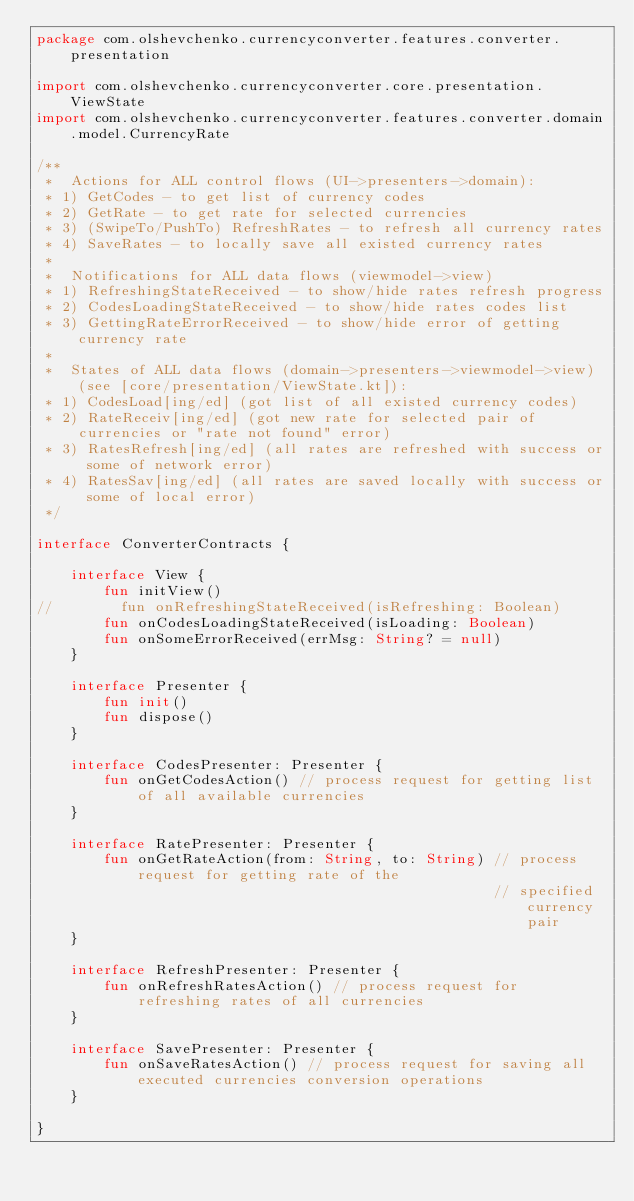<code> <loc_0><loc_0><loc_500><loc_500><_Kotlin_>package com.olshevchenko.currencyconverter.features.converter.presentation

import com.olshevchenko.currencyconverter.core.presentation.ViewState
import com.olshevchenko.currencyconverter.features.converter.domain.model.CurrencyRate

/**
 *  Actions for ALL control flows (UI->presenters->domain):
 * 1) GetCodes - to get list of currency codes
 * 2) GetRate - to get rate for selected currencies
 * 3) (SwipeTo/PushTo) RefreshRates - to refresh all currency rates
 * 4) SaveRates - to locally save all existed currency rates
 *
 *  Notifications for ALL data flows (viewmodel->view)
 * 1) RefreshingStateReceived - to show/hide rates refresh progress
 * 2) CodesLoadingStateReceived - to show/hide rates codes list
 * 3) GettingRateErrorReceived - to show/hide error of getting currency rate
 *
 *  States of ALL data flows (domain->presenters->viewmodel->view) (see [core/presentation/ViewState.kt]):
 * 1) CodesLoad[ing/ed] (got list of all existed currency codes)
 * 2) RateReceiv[ing/ed] (got new rate for selected pair of currencies or "rate not found" error)
 * 3) RatesRefresh[ing/ed] (all rates are refreshed with success or some of network error)
 * 4) RatesSav[ing/ed] (all rates are saved locally with success or some of local error)
 */

interface ConverterContracts {

    interface View {
        fun initView()
//        fun onRefreshingStateReceived(isRefreshing: Boolean)
        fun onCodesLoadingStateReceived(isLoading: Boolean)
        fun onSomeErrorReceived(errMsg: String? = null)
    }

    interface Presenter {
        fun init()
        fun dispose()
    }

    interface CodesPresenter: Presenter {
        fun onGetCodesAction() // process request for getting list of all available currencies
    }

    interface RatePresenter: Presenter {
        fun onGetRateAction(from: String, to: String) // process request for getting rate of the
                                                      // specified currency pair
    }

    interface RefreshPresenter: Presenter {
        fun onRefreshRatesAction() // process request for refreshing rates of all currencies
    }

    interface SavePresenter: Presenter {
        fun onSaveRatesAction() // process request for saving all executed currencies conversion operations
    }

}</code> 